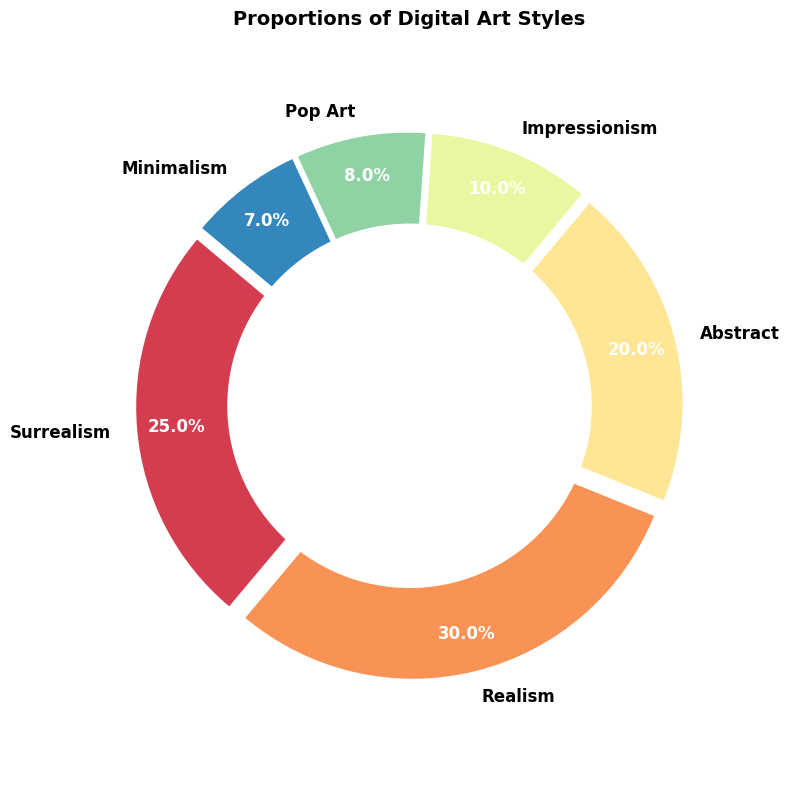Which digital art style has the largest proportion? To determine which art style has the largest proportion, look at the slices of the donut chart and their respective percentage values; the slice with the largest value represents the largest proportion.
Answer: Realism What is the combined proportion of Surrealism and Abstract art styles? We need to add the proportion values for Surrealism (25%) and Abstract (20%). Therefore, 25 + 20 = 45.
Answer: 45% Which art style has a smaller proportion, Impressionism or Minimalism? Compare the percentage values of Impressionism (10%) and Minimalism (7%) in the chart. Minimalism has the smaller proportion.
Answer: Minimalism How does the proportion of Realism compare to Pop Art? Look at the proportion values for Realism (30%) and Pop Art (8%) in the chart. Realism has a significantly larger proportion compared to Pop Art.
Answer: Realism What is the difference in proportions between the largest and the smallest art styles? Find the largest (Realism at 30%) and the smallest (Minimalism at 7%) proportions in the chart. Subtract the smallest from the largest: 30 - 7 = 23.
Answer: 23% Which art styles, combined, account for less than 20% of the total proportion? Sum the proportions of the smaller art styles: Pop Art (8%) and Minimalism (7%). Therefore, 8 + 7 = 15, which is less than 20%.
Answer: Pop Art and Minimalism If Impressionism and Pop Art were combined into one category, what would be their total proportion? Add the proportions of Impressionism (10%) and Pop Art (8%). Thus, 10 + 8 = 18.
Answer: 18% What percentage more does Realism contribute compared to Abstract? Subtract the proportion of Abstract (20%) from Realism (30%). Therefore, 30 - 20 = 10%.
Answer: 10% Which segment is colored with the most distinct color, and can you describe its position? Since all sections have different colors and are distinctly visible, the largest slice, Realism, is the most visually distinct. It is located at the bottom left part of the donut chart starting from the 140 degrees position.
Answer: Realism How many art styles have a proportion larger than 10%? By inspecting the chart, count the art styles with values over 10%: Surrealism (25%), Realism (30%), and Abstract (20%). There are 3 in total.
Answer: 3 